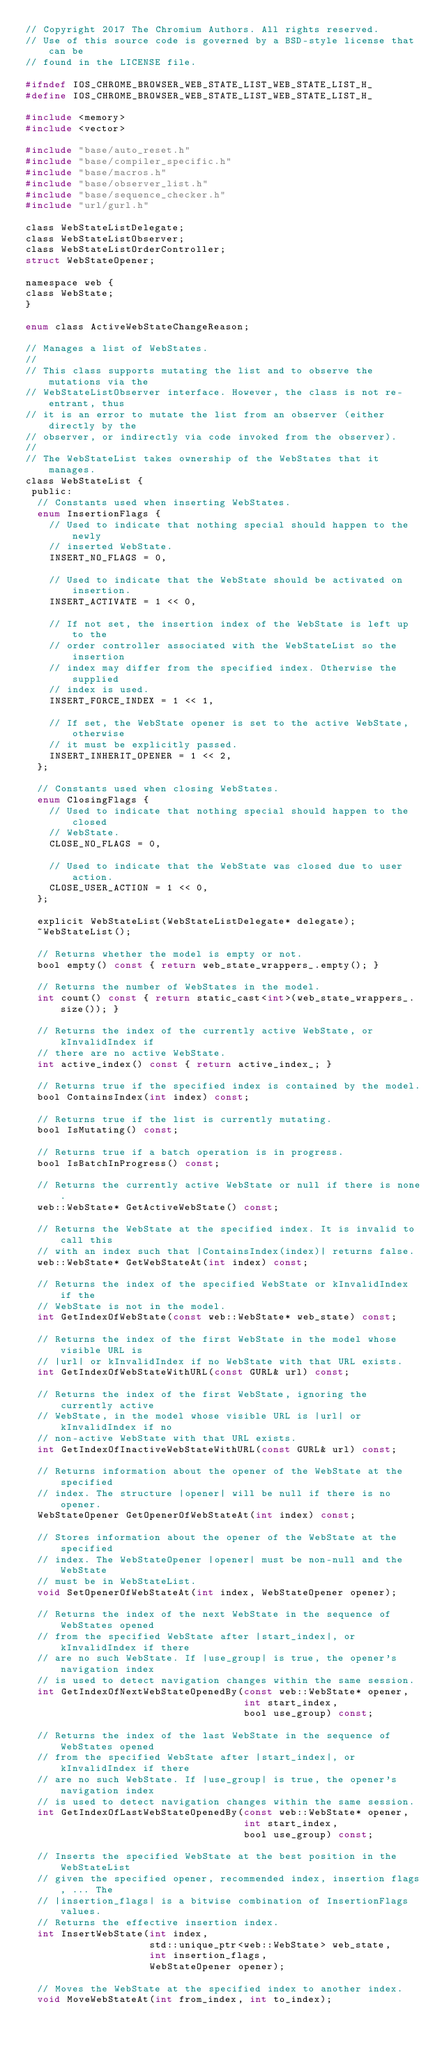Convert code to text. <code><loc_0><loc_0><loc_500><loc_500><_C_>// Copyright 2017 The Chromium Authors. All rights reserved.
// Use of this source code is governed by a BSD-style license that can be
// found in the LICENSE file.

#ifndef IOS_CHROME_BROWSER_WEB_STATE_LIST_WEB_STATE_LIST_H_
#define IOS_CHROME_BROWSER_WEB_STATE_LIST_WEB_STATE_LIST_H_

#include <memory>
#include <vector>

#include "base/auto_reset.h"
#include "base/compiler_specific.h"
#include "base/macros.h"
#include "base/observer_list.h"
#include "base/sequence_checker.h"
#include "url/gurl.h"

class WebStateListDelegate;
class WebStateListObserver;
class WebStateListOrderController;
struct WebStateOpener;

namespace web {
class WebState;
}

enum class ActiveWebStateChangeReason;

// Manages a list of WebStates.
//
// This class supports mutating the list and to observe the mutations via the
// WebStateListObserver interface. However, the class is not re-entrant, thus
// it is an error to mutate the list from an observer (either directly by the
// observer, or indirectly via code invoked from the observer).
//
// The WebStateList takes ownership of the WebStates that it manages.
class WebStateList {
 public:
  // Constants used when inserting WebStates.
  enum InsertionFlags {
    // Used to indicate that nothing special should happen to the newly
    // inserted WebState.
    INSERT_NO_FLAGS = 0,

    // Used to indicate that the WebState should be activated on insertion.
    INSERT_ACTIVATE = 1 << 0,

    // If not set, the insertion index of the WebState is left up to the
    // order controller associated with the WebStateList so the insertion
    // index may differ from the specified index. Otherwise the supplied
    // index is used.
    INSERT_FORCE_INDEX = 1 << 1,

    // If set, the WebState opener is set to the active WebState, otherwise
    // it must be explicitly passed.
    INSERT_INHERIT_OPENER = 1 << 2,
  };

  // Constants used when closing WebStates.
  enum ClosingFlags {
    // Used to indicate that nothing special should happen to the closed
    // WebState.
    CLOSE_NO_FLAGS = 0,

    // Used to indicate that the WebState was closed due to user action.
    CLOSE_USER_ACTION = 1 << 0,
  };

  explicit WebStateList(WebStateListDelegate* delegate);
  ~WebStateList();

  // Returns whether the model is empty or not.
  bool empty() const { return web_state_wrappers_.empty(); }

  // Returns the number of WebStates in the model.
  int count() const { return static_cast<int>(web_state_wrappers_.size()); }

  // Returns the index of the currently active WebState, or kInvalidIndex if
  // there are no active WebState.
  int active_index() const { return active_index_; }

  // Returns true if the specified index is contained by the model.
  bool ContainsIndex(int index) const;

  // Returns true if the list is currently mutating.
  bool IsMutating() const;

  // Returns true if a batch operation is in progress.
  bool IsBatchInProgress() const;

  // Returns the currently active WebState or null if there is none.
  web::WebState* GetActiveWebState() const;

  // Returns the WebState at the specified index. It is invalid to call this
  // with an index such that |ContainsIndex(index)| returns false.
  web::WebState* GetWebStateAt(int index) const;

  // Returns the index of the specified WebState or kInvalidIndex if the
  // WebState is not in the model.
  int GetIndexOfWebState(const web::WebState* web_state) const;

  // Returns the index of the first WebState in the model whose visible URL is
  // |url| or kInvalidIndex if no WebState with that URL exists.
  int GetIndexOfWebStateWithURL(const GURL& url) const;

  // Returns the index of the first WebState, ignoring the currently active
  // WebState, in the model whose visible URL is |url| or kInvalidIndex if no
  // non-active WebState with that URL exists.
  int GetIndexOfInactiveWebStateWithURL(const GURL& url) const;

  // Returns information about the opener of the WebState at the specified
  // index. The structure |opener| will be null if there is no opener.
  WebStateOpener GetOpenerOfWebStateAt(int index) const;

  // Stores information about the opener of the WebState at the specified
  // index. The WebStateOpener |opener| must be non-null and the WebState
  // must be in WebStateList.
  void SetOpenerOfWebStateAt(int index, WebStateOpener opener);

  // Returns the index of the next WebState in the sequence of WebStates opened
  // from the specified WebState after |start_index|, or kInvalidIndex if there
  // are no such WebState. If |use_group| is true, the opener's navigation index
  // is used to detect navigation changes within the same session.
  int GetIndexOfNextWebStateOpenedBy(const web::WebState* opener,
                                     int start_index,
                                     bool use_group) const;

  // Returns the index of the last WebState in the sequence of WebStates opened
  // from the specified WebState after |start_index|, or kInvalidIndex if there
  // are no such WebState. If |use_group| is true, the opener's navigation index
  // is used to detect navigation changes within the same session.
  int GetIndexOfLastWebStateOpenedBy(const web::WebState* opener,
                                     int start_index,
                                     bool use_group) const;

  // Inserts the specified WebState at the best position in the WebStateList
  // given the specified opener, recommended index, insertion flags, ... The
  // |insertion_flags| is a bitwise combination of InsertionFlags values.
  // Returns the effective insertion index.
  int InsertWebState(int index,
                     std::unique_ptr<web::WebState> web_state,
                     int insertion_flags,
                     WebStateOpener opener);

  // Moves the WebState at the specified index to another index.
  void MoveWebStateAt(int from_index, int to_index);
</code> 